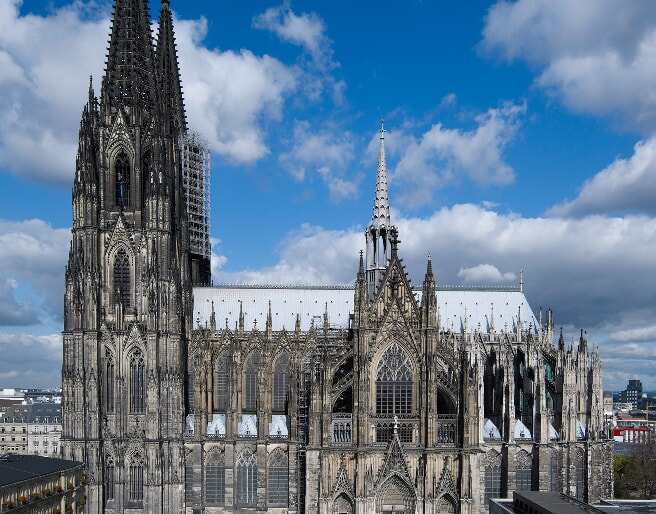If you were to write a poem inspired by the Cologne Cathedral, what would it be? Amidst the Rhine’s enduring flow,
Stands a grandeur steeped in time’s glow,
Cologne’s spires pierce azure skies,
Their tales written in stone cries.

With arches high and buttresses wide,
Crafted dreams of old, enshrined with pride,
Ancient whispers in the night,
Of craftsmen’s toil, through dawn’s first light.

Stained glass whispers stories told,
Of kings and saints in colors bold,
Sunlight dances through divine hymns,
Casting rainbows on faithful limbs.

Warrior of time, withstands the fray,
Guardian of faith, come what may,
A beacon tall to those afar,
Gothic star, where prayers are.

Silent sentinel, through ages vast,
Echoes of the present meet the past,
Oh Cologne, your heart in stone,
In your shadow, we’re not alone. 